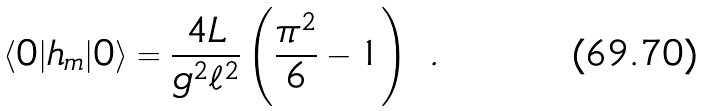<formula> <loc_0><loc_0><loc_500><loc_500>\langle 0 | h _ { m } | 0 \rangle = \frac { 4 L } { g ^ { 2 } \ell ^ { 2 } } \left ( \frac { \pi ^ { 2 } } { 6 } - 1 \right ) \ .</formula> 